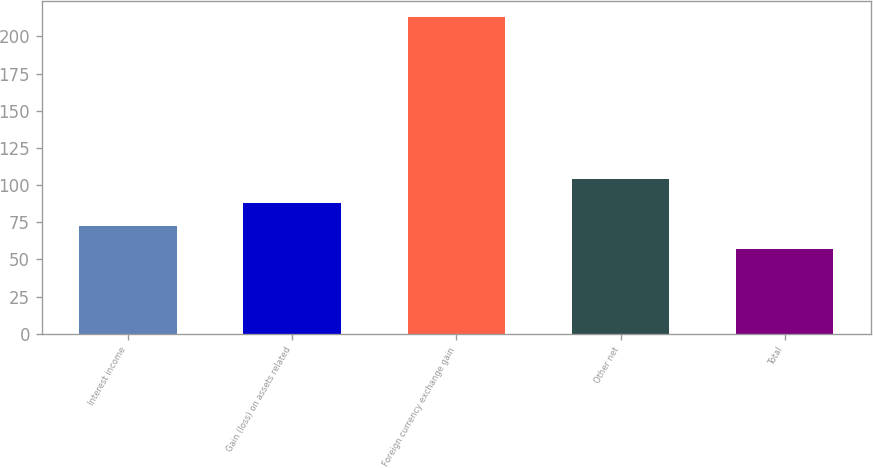Convert chart. <chart><loc_0><loc_0><loc_500><loc_500><bar_chart><fcel>Interest income<fcel>Gain (loss) on assets related<fcel>Foreign currency exchange gain<fcel>Other net<fcel>Total<nl><fcel>72.6<fcel>88.2<fcel>213<fcel>103.8<fcel>57<nl></chart> 